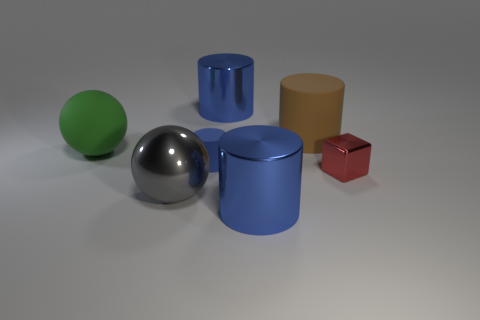Add 2 tiny yellow metallic cylinders. How many objects exist? 9 Subtract all brown rubber cylinders. How many cylinders are left? 3 Subtract all gray balls. How many balls are left? 1 Subtract all spheres. How many objects are left? 5 Subtract all brown cylinders. How many cyan blocks are left? 0 Subtract all green rubber balls. Subtract all small red shiny objects. How many objects are left? 5 Add 5 green spheres. How many green spheres are left? 6 Add 1 yellow objects. How many yellow objects exist? 1 Subtract 0 cyan balls. How many objects are left? 7 Subtract 1 cylinders. How many cylinders are left? 3 